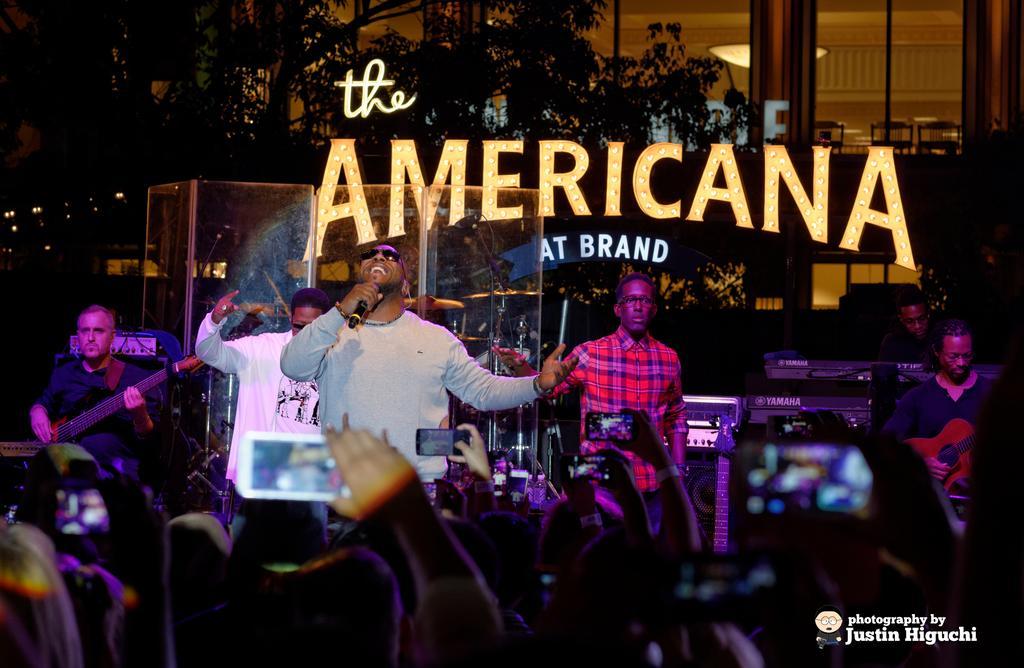In one or two sentences, can you explain what this image depicts? This is a picture taken in a hotel, on the stage there are the group of people performing the music. The person in the middle of the stage holding a microphone and singing a song. In front off this people these are the audience recording their performance through mobile phones. Background of this people is a tree and a hotel. 